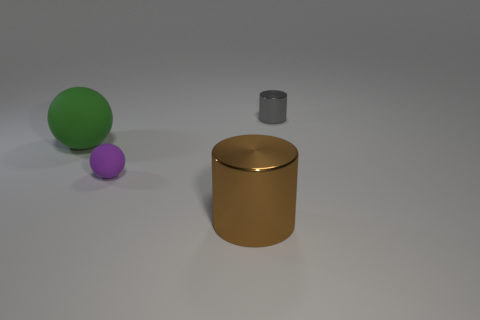Add 4 yellow rubber balls. How many objects exist? 8 Subtract 1 brown cylinders. How many objects are left? 3 Subtract 2 spheres. How many spheres are left? 0 Subtract all gray spheres. Subtract all purple blocks. How many spheres are left? 2 Subtract all yellow cylinders. How many purple balls are left? 1 Subtract all large cylinders. Subtract all big brown things. How many objects are left? 2 Add 2 large brown shiny cylinders. How many large brown shiny cylinders are left? 3 Add 2 small purple shiny cylinders. How many small purple shiny cylinders exist? 2 